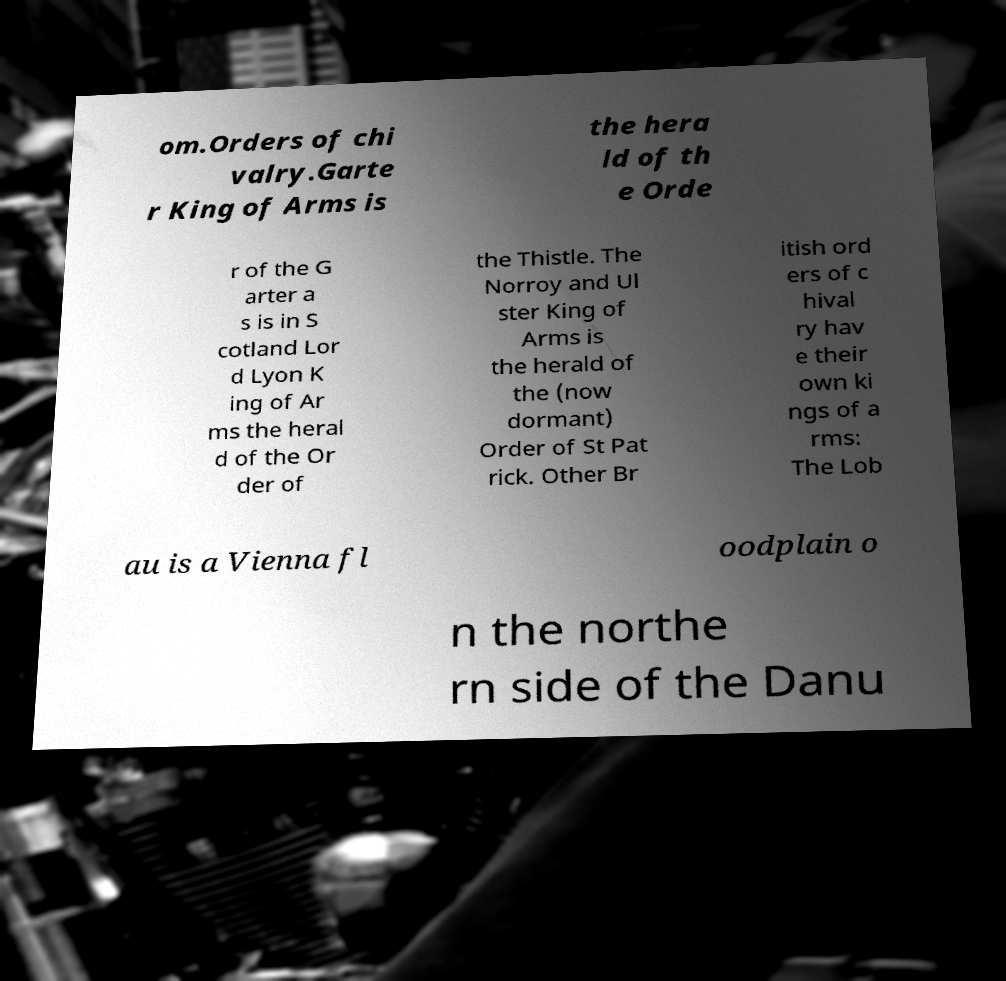There's text embedded in this image that I need extracted. Can you transcribe it verbatim? om.Orders of chi valry.Garte r King of Arms is the hera ld of th e Orde r of the G arter a s is in S cotland Lor d Lyon K ing of Ar ms the heral d of the Or der of the Thistle. The Norroy and Ul ster King of Arms is the herald of the (now dormant) Order of St Pat rick. Other Br itish ord ers of c hival ry hav e their own ki ngs of a rms: The Lob au is a Vienna fl oodplain o n the northe rn side of the Danu 